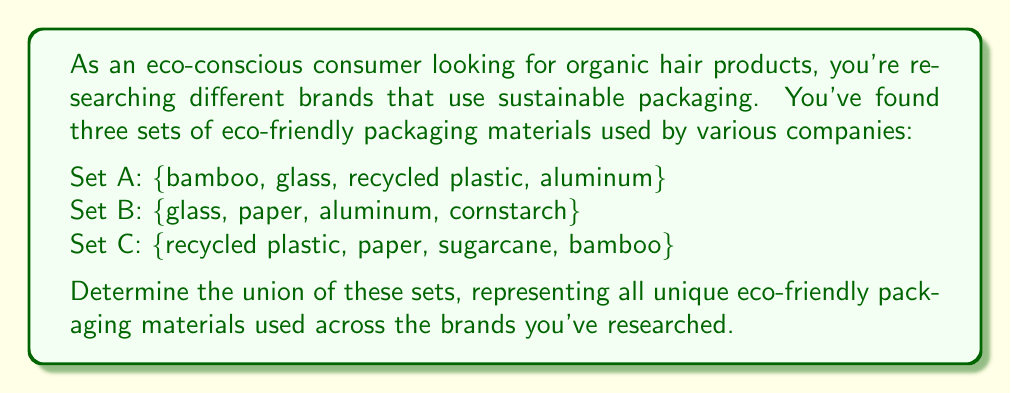Solve this math problem. To find the union of these sets, we need to combine all unique elements from sets A, B, and C. Let's approach this step-by-step:

1. Start with Set A: $\{bamboo, glass, recycled plastic, aluminum\}$

2. Add unique elements from Set B:
   - glass and aluminum are already included
   - Add paper and cornstarch
   Current union: $\{bamboo, glass, recycled plastic, aluminum, paper, cornstarch\}$

3. Add unique elements from Set C:
   - recycled plastic, paper, and bamboo are already included
   - Add sugarcane
   Final union: $\{bamboo, glass, recycled plastic, aluminum, paper, cornstarch, sugarcane\}$

The union of sets A, B, and C is denoted as $A \cup B \cup C$.

In set notation, this can be written as:

$$A \cup B \cup C = \{x | x \in A \text{ or } x \in B \text{ or } x \in C\}$$

where $x$ represents each element in the resulting set.
Answer: $A \cup B \cup C = \{bamboo, glass, recycled plastic, aluminum, paper, cornstarch, sugarcane\}$ 